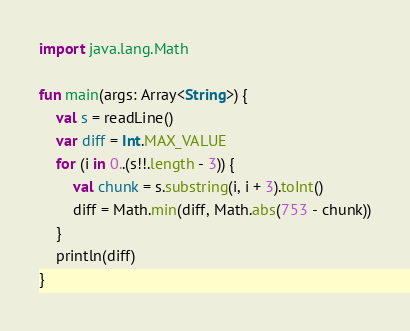<code> <loc_0><loc_0><loc_500><loc_500><_Kotlin_>import java.lang.Math

fun main(args: Array<String>) {
    val s = readLine()
    var diff = Int.MAX_VALUE
    for (i in 0..(s!!.length - 3)) {
        val chunk = s.substring(i, i + 3).toInt()
        diff = Math.min(diff, Math.abs(753 - chunk))
    }
    println(diff)
}
</code> 